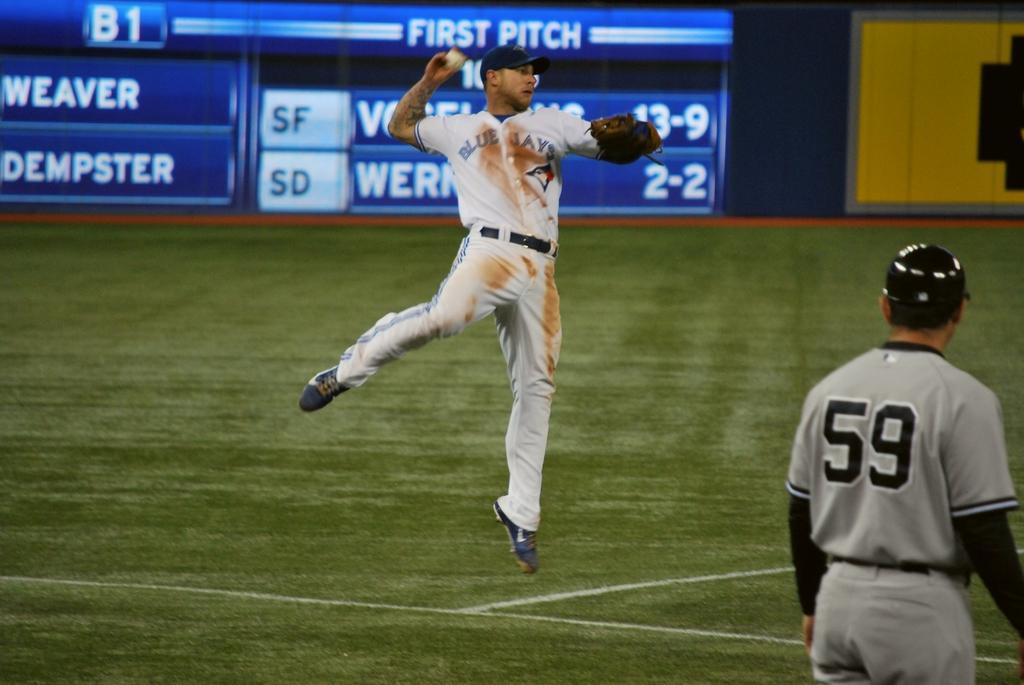How would you summarize this image in a sentence or two? In the background we can see scoreboard. We can see a man wearing a cap. He is holding a ball in his hand. On the right side of the picture we can see another person. This is a playground. 